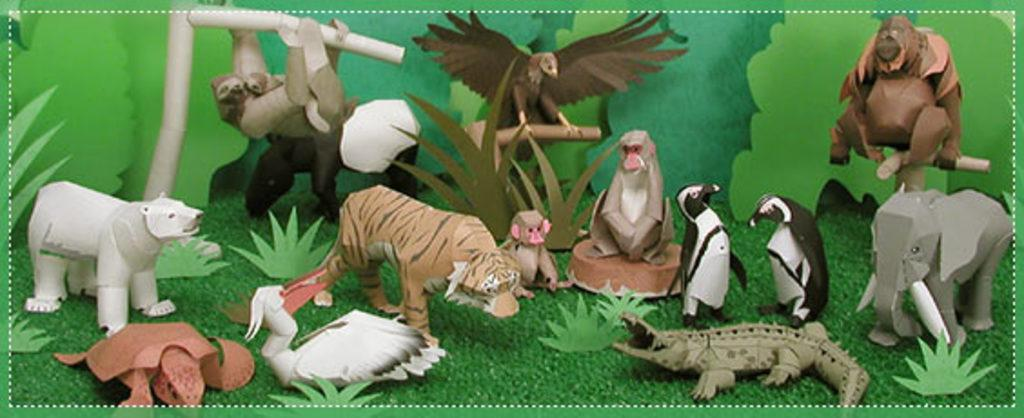What type of toys are in the middle of the image? There are animal toys in the middle of the image. What is the ground made of in the image? The ground has grass. How are the toys arranged in the image? The arrangement of the toys may resemble an art piece. What song is being sung by the toys in the image? There are no toys singing in the image; they are simply arranged on the grass. 